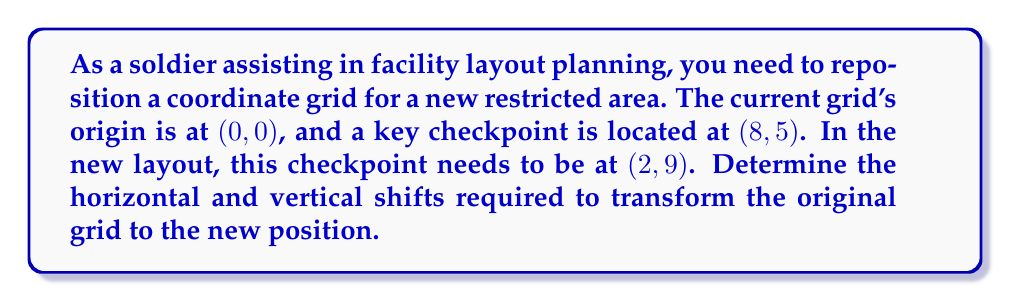What is the answer to this math problem? To solve this problem, we need to find the horizontal and vertical shifts that will move the point (8, 5) to (2, 9). Let's approach this step-by-step:

1. Horizontal shift:
   - The x-coordinate needs to change from 8 to 2.
   - The shift is calculated by subtracting the original x-coordinate from the new x-coordinate.
   - Horizontal shift = $2 - 8 = -6$
   - A negative shift means we're moving 6 units to the left.

2. Vertical shift:
   - The y-coordinate needs to change from 5 to 9.
   - The shift is calculated by subtracting the original y-coordinate from the new y-coordinate.
   - Vertical shift = $9 - 5 = 4$
   - A positive shift means we're moving 4 units up.

3. Expressing the transformation:
   - For any point (x, y) on the original grid, its new position (x', y') after the transformation will be:
     $x' = x - 6$
     $y' = y + 4$

4. Verification:
   - Let's apply this transformation to the original checkpoint (8, 5):
     $x' = 8 - 6 = 2$
     $y' = 5 + 4 = 9$
   - This correctly gives us the new position (2, 9).

Therefore, to reposition the coordinate grid, we need to shift it 6 units left and 4 units up.
Answer: The required transformations are:
Horizontal shift: -6 units (left)
Vertical shift: +4 units (up) 